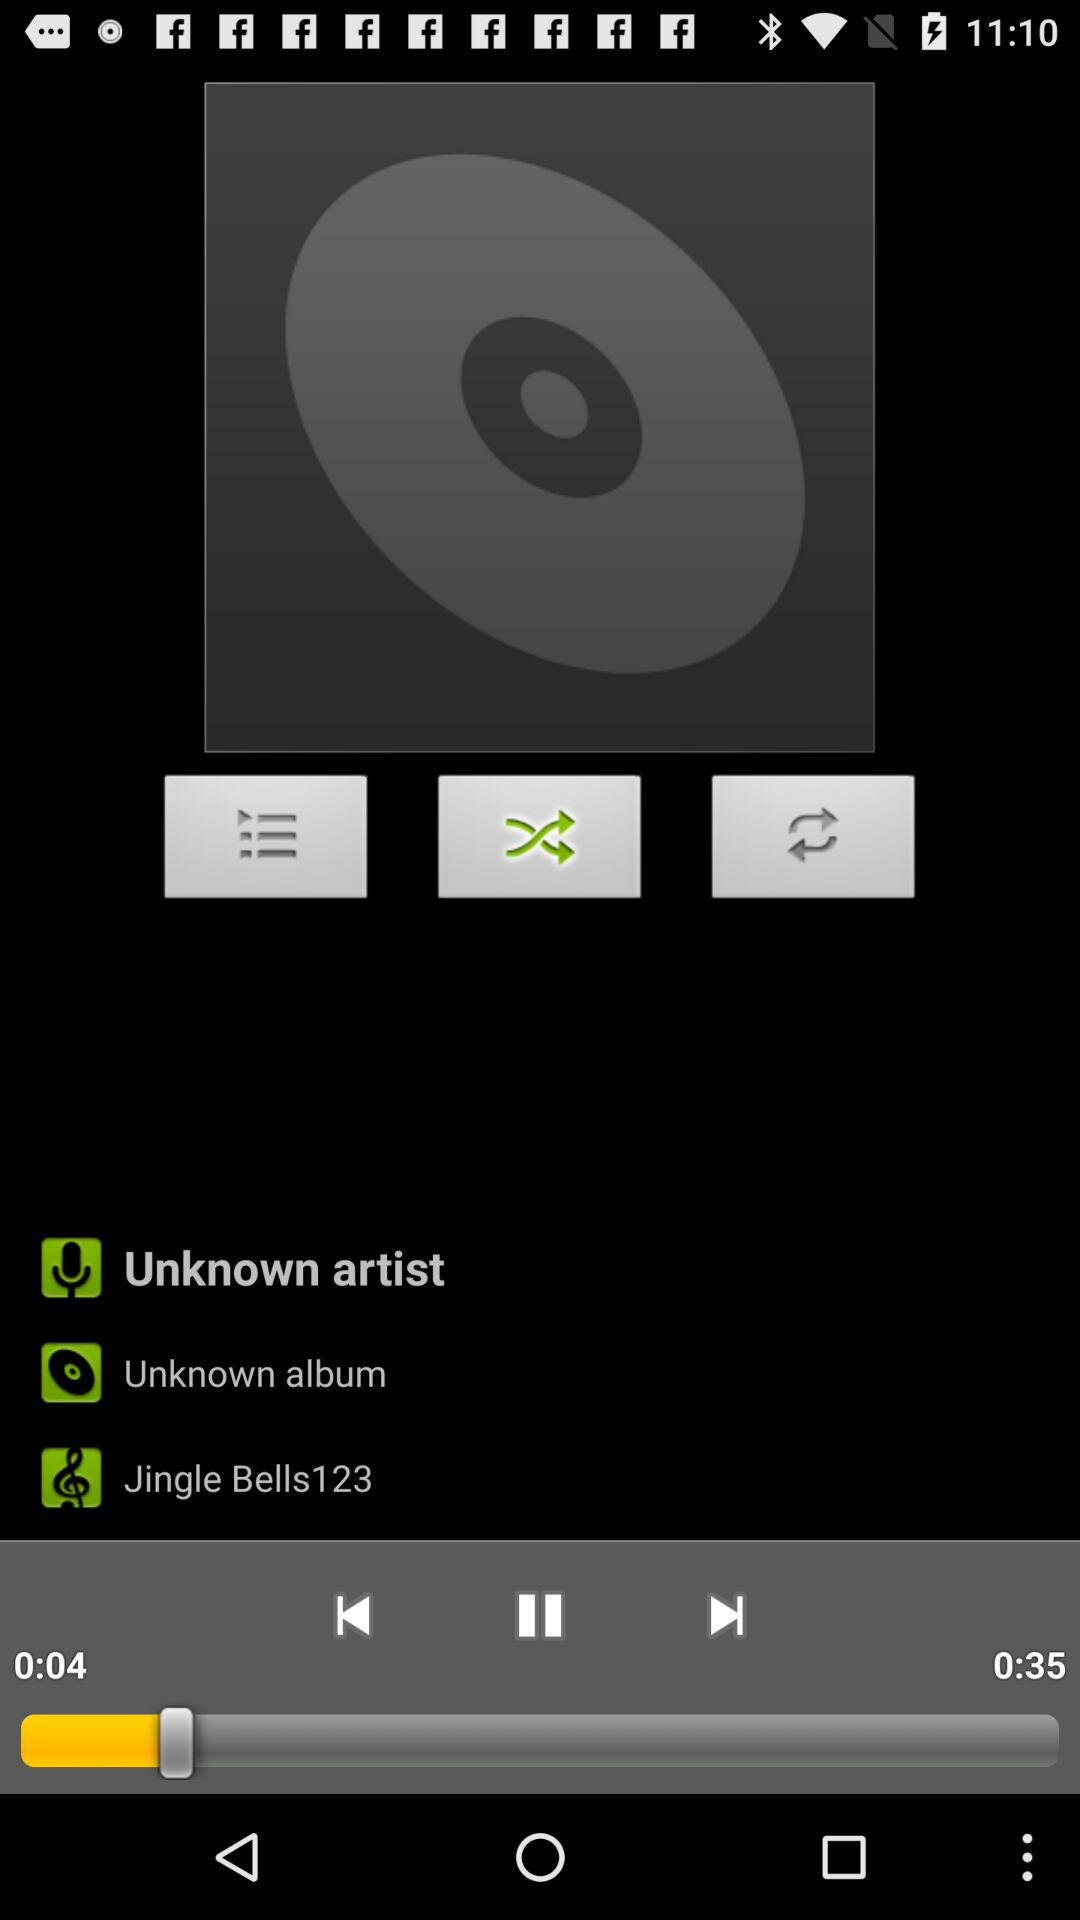Which song is playing? The song is "Jingle Bells123". 